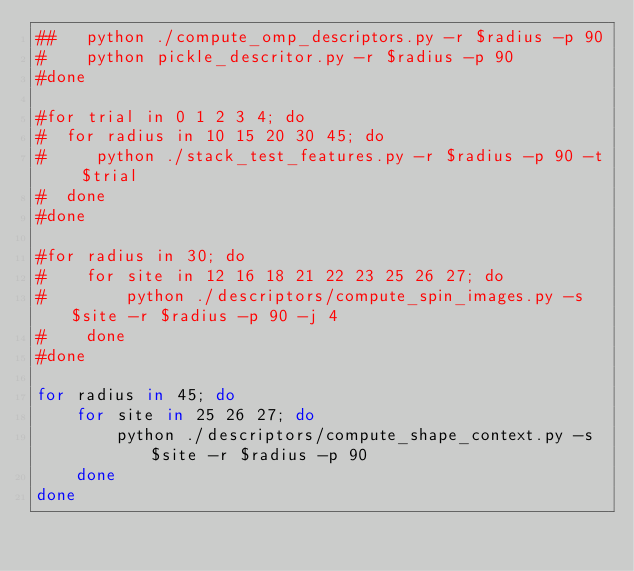<code> <loc_0><loc_0><loc_500><loc_500><_Bash_>##   python ./compute_omp_descriptors.py -r $radius -p 90
#    python pickle_descritor.py -r $radius -p 90
#done

#for trial in 0 1 2 3 4; do
#  for radius in 10 15 20 30 45; do
#     python ./stack_test_features.py -r $radius -p 90 -t $trial
#  done
#done

#for radius in 30; do
#    for site in 12 16 18 21 22 23 25 26 27; do
#        python ./descriptors/compute_spin_images.py -s $site -r $radius -p 90 -j 4
#    done
#done

for radius in 45; do
    for site in 25 26 27; do
        python ./descriptors/compute_shape_context.py -s $site -r $radius -p 90
    done
done</code> 